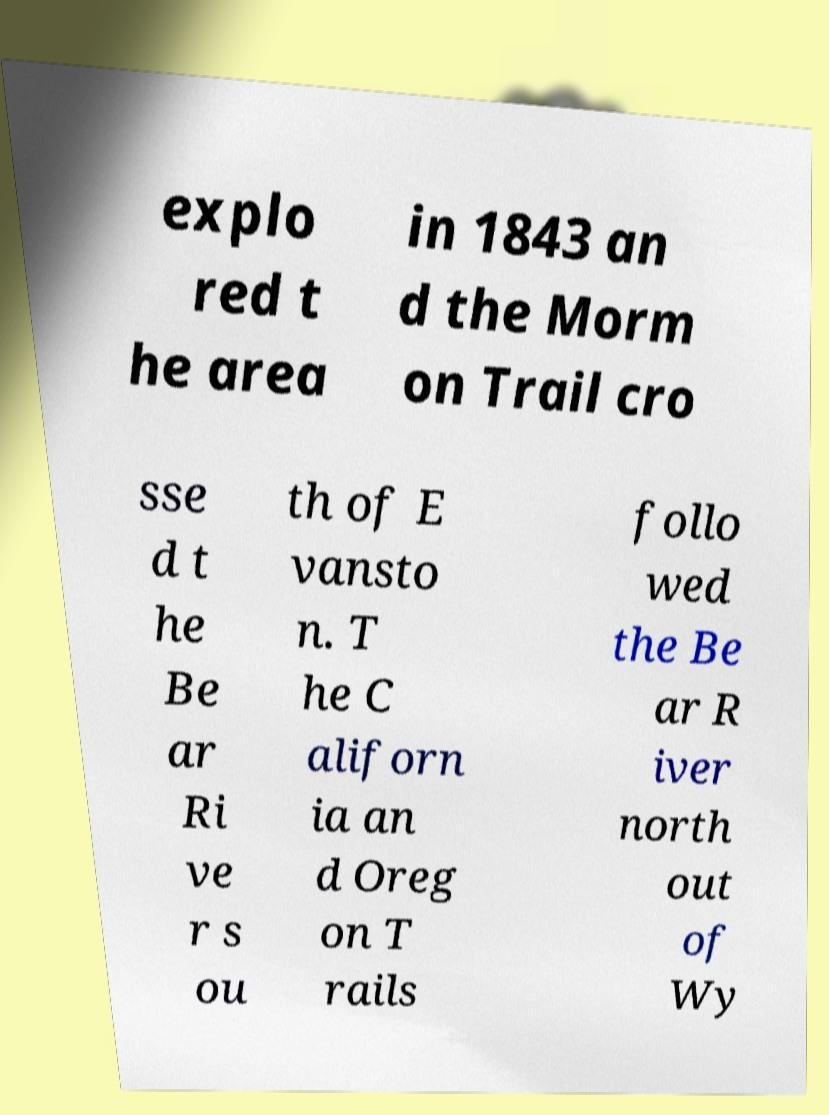What messages or text are displayed in this image? I need them in a readable, typed format. explo red t he area in 1843 an d the Morm on Trail cro sse d t he Be ar Ri ve r s ou th of E vansto n. T he C aliforn ia an d Oreg on T rails follo wed the Be ar R iver north out of Wy 